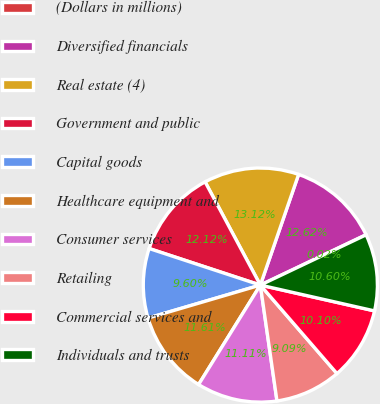Convert chart. <chart><loc_0><loc_0><loc_500><loc_500><pie_chart><fcel>(Dollars in millions)<fcel>Diversified financials<fcel>Real estate (4)<fcel>Government and public<fcel>Capital goods<fcel>Healthcare equipment and<fcel>Consumer services<fcel>Retailing<fcel>Commercial services and<fcel>Individuals and trusts<nl><fcel>0.02%<fcel>12.62%<fcel>13.12%<fcel>12.12%<fcel>9.6%<fcel>11.61%<fcel>11.11%<fcel>9.09%<fcel>10.1%<fcel>10.6%<nl></chart> 